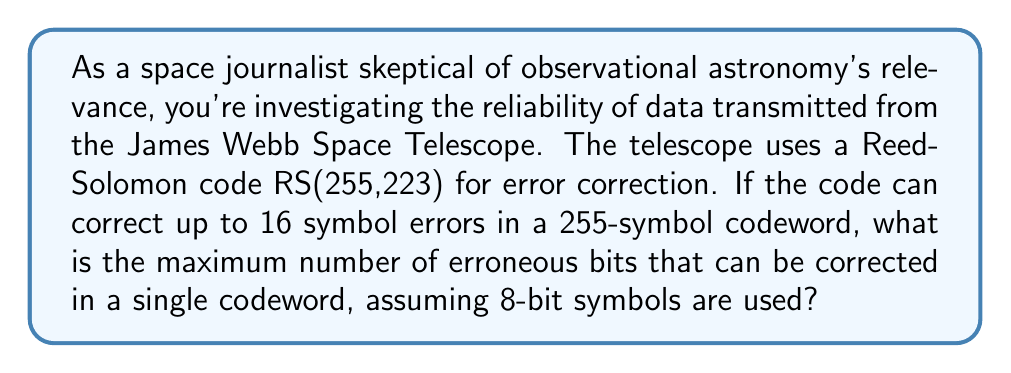Solve this math problem. To solve this problem, we need to understand the properties of Reed-Solomon codes and how they relate to bit-level error correction:

1) Reed-Solomon Code Structure:
   - The code is RS(255,223), where:
     - 255 is the total number of symbols in a codeword
     - 223 is the number of data symbols
     - 32 (255 - 223) is the number of parity symbols

2) Error Correction Capability:
   - The code can correct up to 16 symbol errors.
   - In Reed-Solomon codes, the number of correctable symbols $t$ is given by:
     $$t = \frac{n - k}{2}$$
     where $n$ is the total number of symbols and $k$ is the number of data symbols.
   - Indeed, $\frac{255 - 223}{2} = 16$

3) Symbol Size:
   - Each symbol is 8 bits (1 byte) in size.

4) Maximum Bit Errors:
   - The worst-case scenario for bit errors is when each erroneous symbol has only 1 bit flipped.
   - In this case, each symbol error corresponds to 1 bit error.
   - Therefore, the maximum number of bit errors that can be corrected is:
     $$\text{Max Bit Errors} = 16 \text{ symbols} \times 8 \text{ bits/symbol} = 128 \text{ bits}$$

This result shows that while the code can correct up to 16 symbol errors, it can potentially correct up to 128 bit errors if they are optimally distributed across different symbols.
Answer: 128 bits 